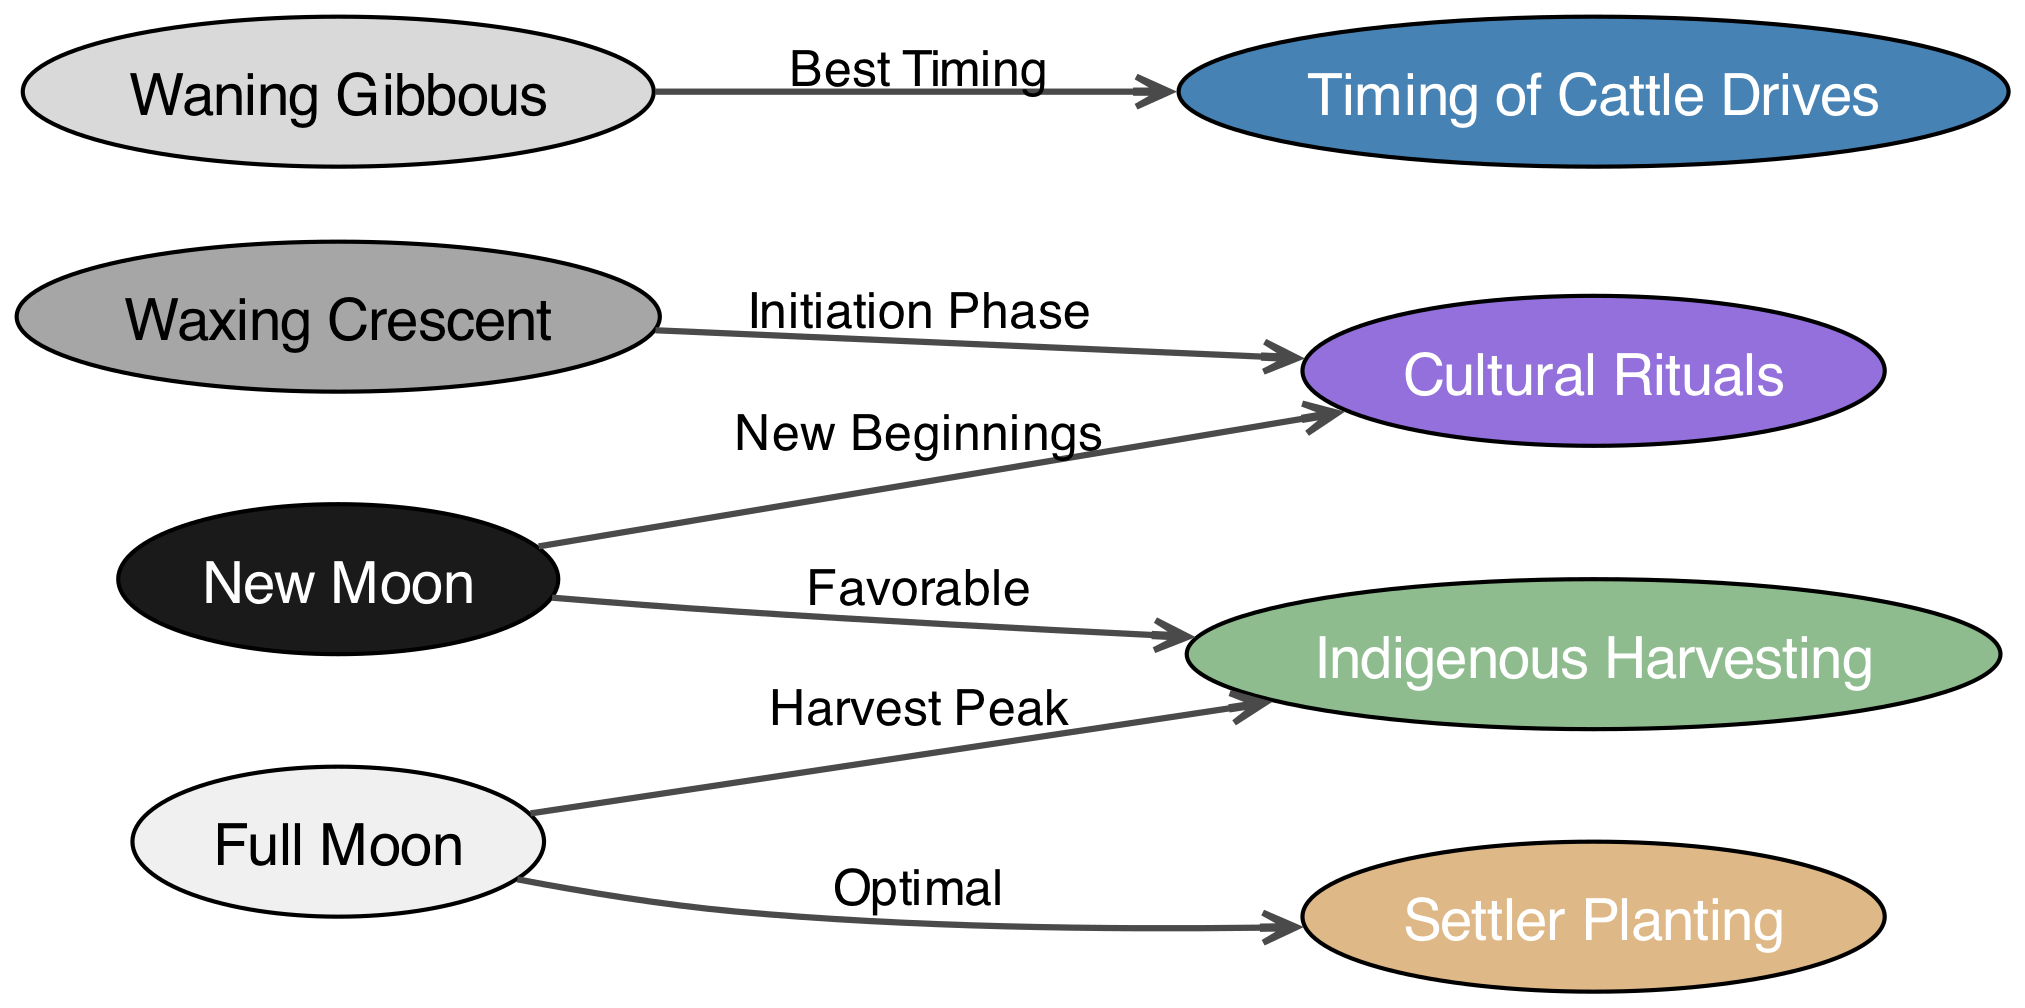What nodes are connected to the New Moon? The New Moon node is connected to the Indigenous Harvesting node with a "Favorable" label, the Rituals node with a "New Beginnings" label.
Answer: Indigenous Harvesting, Rituals How many edges are in the diagram? To calculate the number of edges, we can count the relationships shown in the diagram: there are 6 edges connecting various nodes.
Answer: 6 What is the relationship between the Full Moon and Settler Planting? The relationship between the Full Moon and Settler Planting is described with the label "Optimal".
Answer: Optimal Which phases are favorable for Indigenous Harvesting? The phases favorable for Indigenous Harvesting are the New Moon and Full Moon. Connecting edges indicate these relationships.
Answer: New Moon, Full Moon What does the Waxing Crescent phase influence? The Waxing Crescent phase influences the initiation of Cultural Rituals, as indicated by the connecting edge with the label "Initiation Phase".
Answer: Rituals How does the Waning Gibbous relate to Timing? The Waning Gibbous is linked to the Timing of Cattle Drives through the edge labeled "Best Timing", indicating its significance in scheduling cattle drives.
Answer: Best Timing Which lunar phase has two connections to Indigenous Harvesting? The Full Moon has two connections to Indigenous Harvesting: one labeled "Harvest Peak" and another connection to the New Moon labeled "Favorable".
Answer: Full Moon What is the total number of unique lunar phases depicted in the diagram? The unique lunar phases depicted in the diagram include New Moon, Full Moon, Waxing Crescent, and Waning Gibbous, totaling 4 phases.
Answer: 4 